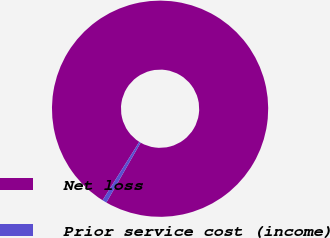Convert chart. <chart><loc_0><loc_0><loc_500><loc_500><pie_chart><fcel>Net loss<fcel>Prior service cost (income)<nl><fcel>99.35%<fcel>0.65%<nl></chart> 